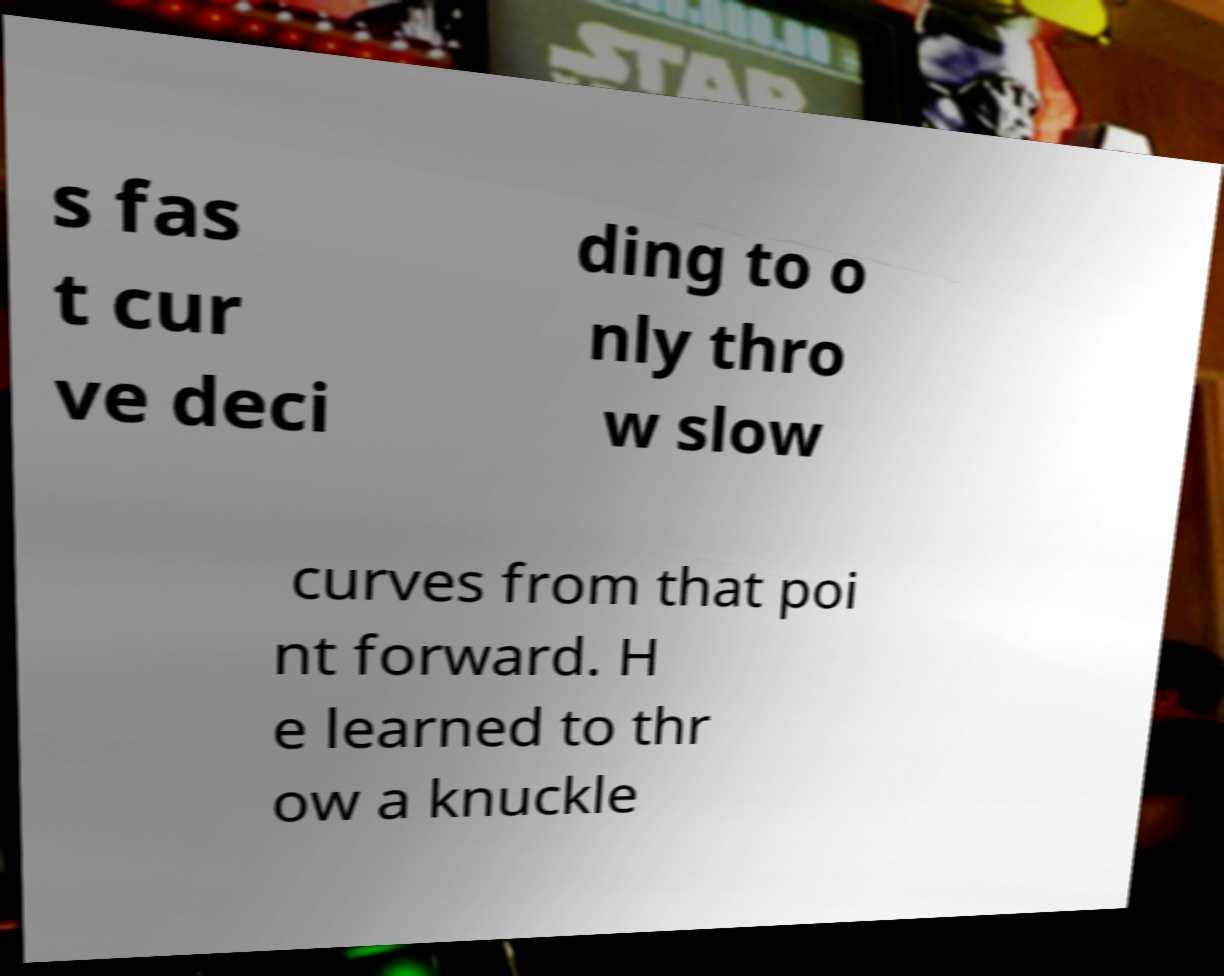Could you assist in decoding the text presented in this image and type it out clearly? s fas t cur ve deci ding to o nly thro w slow curves from that poi nt forward. H e learned to thr ow a knuckle 